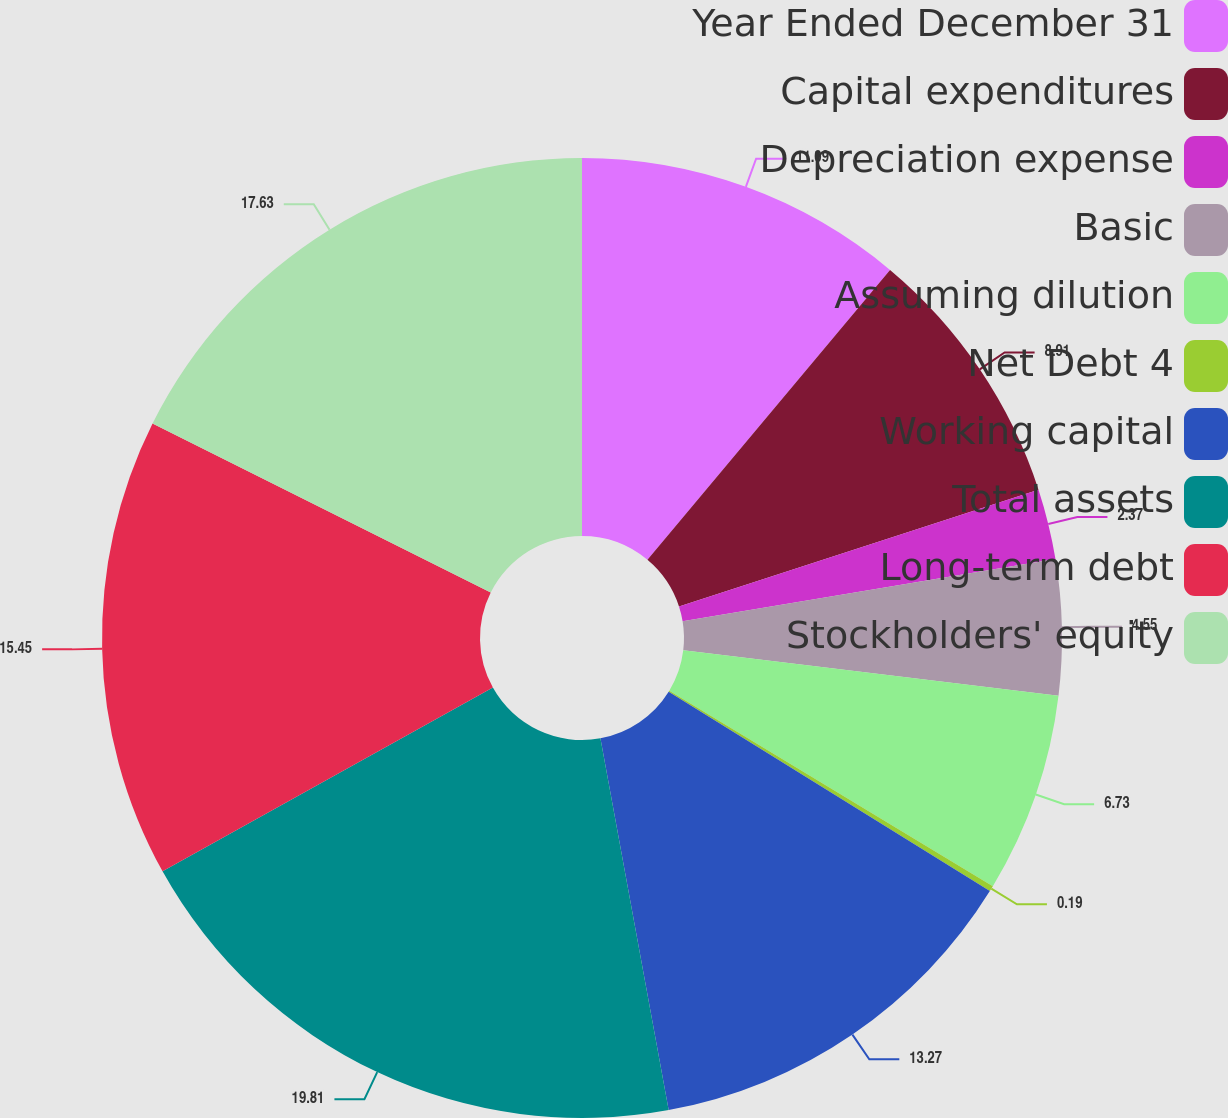Convert chart to OTSL. <chart><loc_0><loc_0><loc_500><loc_500><pie_chart><fcel>Year Ended December 31<fcel>Capital expenditures<fcel>Depreciation expense<fcel>Basic<fcel>Assuming dilution<fcel>Net Debt 4<fcel>Working capital<fcel>Total assets<fcel>Long-term debt<fcel>Stockholders' equity<nl><fcel>11.09%<fcel>8.91%<fcel>2.37%<fcel>4.55%<fcel>6.73%<fcel>0.19%<fcel>13.27%<fcel>19.81%<fcel>15.45%<fcel>17.63%<nl></chart> 